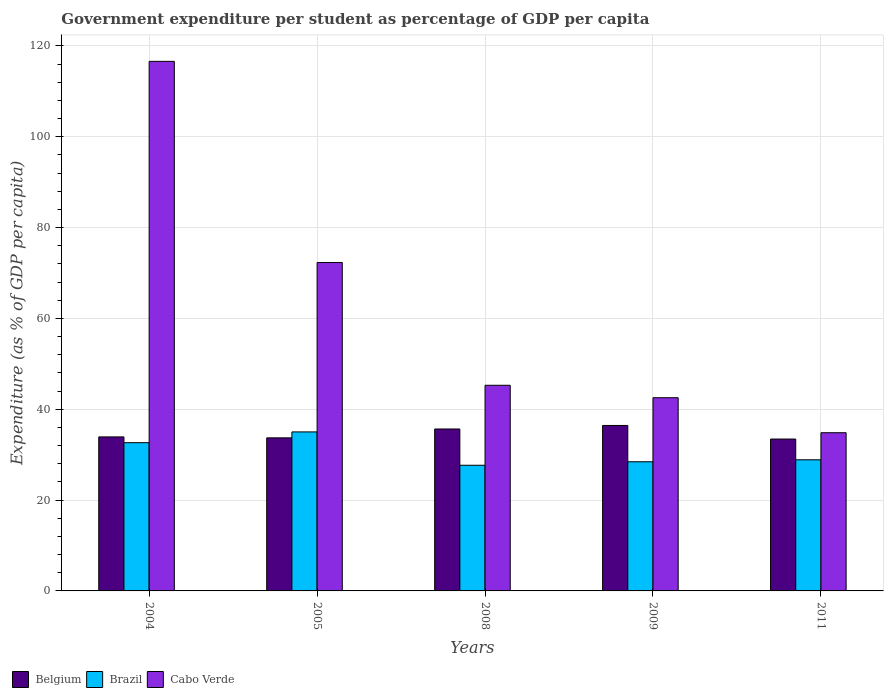Are the number of bars on each tick of the X-axis equal?
Ensure brevity in your answer.  Yes. How many bars are there on the 2nd tick from the left?
Your response must be concise. 3. How many bars are there on the 1st tick from the right?
Keep it short and to the point. 3. What is the label of the 2nd group of bars from the left?
Your answer should be very brief. 2005. In how many cases, is the number of bars for a given year not equal to the number of legend labels?
Provide a short and direct response. 0. What is the percentage of expenditure per student in Cabo Verde in 2008?
Keep it short and to the point. 45.28. Across all years, what is the maximum percentage of expenditure per student in Brazil?
Provide a succinct answer. 35.01. Across all years, what is the minimum percentage of expenditure per student in Brazil?
Offer a terse response. 27.67. What is the total percentage of expenditure per student in Belgium in the graph?
Provide a short and direct response. 173.16. What is the difference between the percentage of expenditure per student in Cabo Verde in 2005 and that in 2008?
Give a very brief answer. 27.03. What is the difference between the percentage of expenditure per student in Cabo Verde in 2008 and the percentage of expenditure per student in Brazil in 2005?
Your answer should be very brief. 10.27. What is the average percentage of expenditure per student in Belgium per year?
Your answer should be very brief. 34.63. In the year 2008, what is the difference between the percentage of expenditure per student in Brazil and percentage of expenditure per student in Belgium?
Make the answer very short. -7.99. What is the ratio of the percentage of expenditure per student in Cabo Verde in 2004 to that in 2005?
Your answer should be very brief. 1.61. Is the percentage of expenditure per student in Brazil in 2005 less than that in 2011?
Keep it short and to the point. No. Is the difference between the percentage of expenditure per student in Brazil in 2008 and 2009 greater than the difference between the percentage of expenditure per student in Belgium in 2008 and 2009?
Your response must be concise. Yes. What is the difference between the highest and the second highest percentage of expenditure per student in Brazil?
Your answer should be very brief. 2.38. What is the difference between the highest and the lowest percentage of expenditure per student in Belgium?
Keep it short and to the point. 2.99. In how many years, is the percentage of expenditure per student in Belgium greater than the average percentage of expenditure per student in Belgium taken over all years?
Offer a terse response. 2. Is the sum of the percentage of expenditure per student in Brazil in 2009 and 2011 greater than the maximum percentage of expenditure per student in Cabo Verde across all years?
Keep it short and to the point. No. What does the 3rd bar from the left in 2004 represents?
Your response must be concise. Cabo Verde. Is it the case that in every year, the sum of the percentage of expenditure per student in Brazil and percentage of expenditure per student in Belgium is greater than the percentage of expenditure per student in Cabo Verde?
Provide a succinct answer. No. How many bars are there?
Provide a succinct answer. 15. How many years are there in the graph?
Your answer should be compact. 5. What is the difference between two consecutive major ticks on the Y-axis?
Your answer should be very brief. 20. Are the values on the major ticks of Y-axis written in scientific E-notation?
Provide a short and direct response. No. How many legend labels are there?
Give a very brief answer. 3. How are the legend labels stacked?
Your answer should be compact. Horizontal. What is the title of the graph?
Provide a succinct answer. Government expenditure per student as percentage of GDP per capita. Does "Madagascar" appear as one of the legend labels in the graph?
Offer a very short reply. No. What is the label or title of the Y-axis?
Your response must be concise. Expenditure (as % of GDP per capita). What is the Expenditure (as % of GDP per capita) of Belgium in 2004?
Offer a very short reply. 33.91. What is the Expenditure (as % of GDP per capita) in Brazil in 2004?
Your response must be concise. 32.64. What is the Expenditure (as % of GDP per capita) of Cabo Verde in 2004?
Keep it short and to the point. 116.61. What is the Expenditure (as % of GDP per capita) in Belgium in 2005?
Your response must be concise. 33.71. What is the Expenditure (as % of GDP per capita) in Brazil in 2005?
Keep it short and to the point. 35.01. What is the Expenditure (as % of GDP per capita) of Cabo Verde in 2005?
Your answer should be very brief. 72.31. What is the Expenditure (as % of GDP per capita) in Belgium in 2008?
Offer a very short reply. 35.66. What is the Expenditure (as % of GDP per capita) of Brazil in 2008?
Provide a succinct answer. 27.67. What is the Expenditure (as % of GDP per capita) of Cabo Verde in 2008?
Your answer should be very brief. 45.28. What is the Expenditure (as % of GDP per capita) in Belgium in 2009?
Make the answer very short. 36.43. What is the Expenditure (as % of GDP per capita) in Brazil in 2009?
Your response must be concise. 28.44. What is the Expenditure (as % of GDP per capita) in Cabo Verde in 2009?
Offer a very short reply. 42.55. What is the Expenditure (as % of GDP per capita) of Belgium in 2011?
Ensure brevity in your answer.  33.44. What is the Expenditure (as % of GDP per capita) of Brazil in 2011?
Your answer should be compact. 28.87. What is the Expenditure (as % of GDP per capita) of Cabo Verde in 2011?
Offer a terse response. 34.84. Across all years, what is the maximum Expenditure (as % of GDP per capita) of Belgium?
Offer a very short reply. 36.43. Across all years, what is the maximum Expenditure (as % of GDP per capita) in Brazil?
Your response must be concise. 35.01. Across all years, what is the maximum Expenditure (as % of GDP per capita) of Cabo Verde?
Your response must be concise. 116.61. Across all years, what is the minimum Expenditure (as % of GDP per capita) of Belgium?
Offer a terse response. 33.44. Across all years, what is the minimum Expenditure (as % of GDP per capita) of Brazil?
Keep it short and to the point. 27.67. Across all years, what is the minimum Expenditure (as % of GDP per capita) in Cabo Verde?
Make the answer very short. 34.84. What is the total Expenditure (as % of GDP per capita) in Belgium in the graph?
Offer a terse response. 173.16. What is the total Expenditure (as % of GDP per capita) of Brazil in the graph?
Keep it short and to the point. 152.64. What is the total Expenditure (as % of GDP per capita) of Cabo Verde in the graph?
Provide a short and direct response. 311.59. What is the difference between the Expenditure (as % of GDP per capita) of Belgium in 2004 and that in 2005?
Keep it short and to the point. 0.21. What is the difference between the Expenditure (as % of GDP per capita) in Brazil in 2004 and that in 2005?
Make the answer very short. -2.38. What is the difference between the Expenditure (as % of GDP per capita) of Cabo Verde in 2004 and that in 2005?
Give a very brief answer. 44.3. What is the difference between the Expenditure (as % of GDP per capita) of Belgium in 2004 and that in 2008?
Your answer should be very brief. -1.75. What is the difference between the Expenditure (as % of GDP per capita) in Brazil in 2004 and that in 2008?
Offer a very short reply. 4.97. What is the difference between the Expenditure (as % of GDP per capita) in Cabo Verde in 2004 and that in 2008?
Provide a succinct answer. 71.33. What is the difference between the Expenditure (as % of GDP per capita) of Belgium in 2004 and that in 2009?
Provide a succinct answer. -2.52. What is the difference between the Expenditure (as % of GDP per capita) of Brazil in 2004 and that in 2009?
Your answer should be compact. 4.2. What is the difference between the Expenditure (as % of GDP per capita) of Cabo Verde in 2004 and that in 2009?
Your response must be concise. 74.07. What is the difference between the Expenditure (as % of GDP per capita) in Belgium in 2004 and that in 2011?
Your answer should be very brief. 0.47. What is the difference between the Expenditure (as % of GDP per capita) in Brazil in 2004 and that in 2011?
Keep it short and to the point. 3.76. What is the difference between the Expenditure (as % of GDP per capita) in Cabo Verde in 2004 and that in 2011?
Offer a terse response. 81.78. What is the difference between the Expenditure (as % of GDP per capita) of Belgium in 2005 and that in 2008?
Provide a succinct answer. -1.95. What is the difference between the Expenditure (as % of GDP per capita) of Brazil in 2005 and that in 2008?
Give a very brief answer. 7.34. What is the difference between the Expenditure (as % of GDP per capita) in Cabo Verde in 2005 and that in 2008?
Offer a terse response. 27.03. What is the difference between the Expenditure (as % of GDP per capita) of Belgium in 2005 and that in 2009?
Provide a succinct answer. -2.73. What is the difference between the Expenditure (as % of GDP per capita) of Brazil in 2005 and that in 2009?
Keep it short and to the point. 6.57. What is the difference between the Expenditure (as % of GDP per capita) of Cabo Verde in 2005 and that in 2009?
Offer a very short reply. 29.77. What is the difference between the Expenditure (as % of GDP per capita) of Belgium in 2005 and that in 2011?
Ensure brevity in your answer.  0.26. What is the difference between the Expenditure (as % of GDP per capita) in Brazil in 2005 and that in 2011?
Ensure brevity in your answer.  6.14. What is the difference between the Expenditure (as % of GDP per capita) of Cabo Verde in 2005 and that in 2011?
Keep it short and to the point. 37.48. What is the difference between the Expenditure (as % of GDP per capita) in Belgium in 2008 and that in 2009?
Give a very brief answer. -0.77. What is the difference between the Expenditure (as % of GDP per capita) in Brazil in 2008 and that in 2009?
Provide a short and direct response. -0.77. What is the difference between the Expenditure (as % of GDP per capita) of Cabo Verde in 2008 and that in 2009?
Provide a short and direct response. 2.74. What is the difference between the Expenditure (as % of GDP per capita) of Belgium in 2008 and that in 2011?
Make the answer very short. 2.21. What is the difference between the Expenditure (as % of GDP per capita) in Brazil in 2008 and that in 2011?
Give a very brief answer. -1.2. What is the difference between the Expenditure (as % of GDP per capita) in Cabo Verde in 2008 and that in 2011?
Your answer should be very brief. 10.45. What is the difference between the Expenditure (as % of GDP per capita) of Belgium in 2009 and that in 2011?
Keep it short and to the point. 2.99. What is the difference between the Expenditure (as % of GDP per capita) in Brazil in 2009 and that in 2011?
Your answer should be compact. -0.43. What is the difference between the Expenditure (as % of GDP per capita) in Cabo Verde in 2009 and that in 2011?
Your answer should be compact. 7.71. What is the difference between the Expenditure (as % of GDP per capita) of Belgium in 2004 and the Expenditure (as % of GDP per capita) of Brazil in 2005?
Make the answer very short. -1.1. What is the difference between the Expenditure (as % of GDP per capita) in Belgium in 2004 and the Expenditure (as % of GDP per capita) in Cabo Verde in 2005?
Provide a short and direct response. -38.4. What is the difference between the Expenditure (as % of GDP per capita) in Brazil in 2004 and the Expenditure (as % of GDP per capita) in Cabo Verde in 2005?
Your answer should be compact. -39.67. What is the difference between the Expenditure (as % of GDP per capita) in Belgium in 2004 and the Expenditure (as % of GDP per capita) in Brazil in 2008?
Keep it short and to the point. 6.24. What is the difference between the Expenditure (as % of GDP per capita) in Belgium in 2004 and the Expenditure (as % of GDP per capita) in Cabo Verde in 2008?
Offer a very short reply. -11.37. What is the difference between the Expenditure (as % of GDP per capita) in Brazil in 2004 and the Expenditure (as % of GDP per capita) in Cabo Verde in 2008?
Your answer should be very brief. -12.65. What is the difference between the Expenditure (as % of GDP per capita) in Belgium in 2004 and the Expenditure (as % of GDP per capita) in Brazil in 2009?
Make the answer very short. 5.47. What is the difference between the Expenditure (as % of GDP per capita) in Belgium in 2004 and the Expenditure (as % of GDP per capita) in Cabo Verde in 2009?
Your answer should be very brief. -8.63. What is the difference between the Expenditure (as % of GDP per capita) of Brazil in 2004 and the Expenditure (as % of GDP per capita) of Cabo Verde in 2009?
Ensure brevity in your answer.  -9.91. What is the difference between the Expenditure (as % of GDP per capita) of Belgium in 2004 and the Expenditure (as % of GDP per capita) of Brazil in 2011?
Ensure brevity in your answer.  5.04. What is the difference between the Expenditure (as % of GDP per capita) of Belgium in 2004 and the Expenditure (as % of GDP per capita) of Cabo Verde in 2011?
Your response must be concise. -0.92. What is the difference between the Expenditure (as % of GDP per capita) of Brazil in 2004 and the Expenditure (as % of GDP per capita) of Cabo Verde in 2011?
Offer a terse response. -2.2. What is the difference between the Expenditure (as % of GDP per capita) of Belgium in 2005 and the Expenditure (as % of GDP per capita) of Brazil in 2008?
Your answer should be compact. 6.04. What is the difference between the Expenditure (as % of GDP per capita) of Belgium in 2005 and the Expenditure (as % of GDP per capita) of Cabo Verde in 2008?
Make the answer very short. -11.58. What is the difference between the Expenditure (as % of GDP per capita) in Brazil in 2005 and the Expenditure (as % of GDP per capita) in Cabo Verde in 2008?
Offer a terse response. -10.27. What is the difference between the Expenditure (as % of GDP per capita) in Belgium in 2005 and the Expenditure (as % of GDP per capita) in Brazil in 2009?
Make the answer very short. 5.27. What is the difference between the Expenditure (as % of GDP per capita) of Belgium in 2005 and the Expenditure (as % of GDP per capita) of Cabo Verde in 2009?
Keep it short and to the point. -8.84. What is the difference between the Expenditure (as % of GDP per capita) of Brazil in 2005 and the Expenditure (as % of GDP per capita) of Cabo Verde in 2009?
Your answer should be very brief. -7.53. What is the difference between the Expenditure (as % of GDP per capita) in Belgium in 2005 and the Expenditure (as % of GDP per capita) in Brazil in 2011?
Make the answer very short. 4.83. What is the difference between the Expenditure (as % of GDP per capita) in Belgium in 2005 and the Expenditure (as % of GDP per capita) in Cabo Verde in 2011?
Your response must be concise. -1.13. What is the difference between the Expenditure (as % of GDP per capita) in Brazil in 2005 and the Expenditure (as % of GDP per capita) in Cabo Verde in 2011?
Give a very brief answer. 0.18. What is the difference between the Expenditure (as % of GDP per capita) in Belgium in 2008 and the Expenditure (as % of GDP per capita) in Brazil in 2009?
Provide a short and direct response. 7.22. What is the difference between the Expenditure (as % of GDP per capita) of Belgium in 2008 and the Expenditure (as % of GDP per capita) of Cabo Verde in 2009?
Offer a very short reply. -6.89. What is the difference between the Expenditure (as % of GDP per capita) of Brazil in 2008 and the Expenditure (as % of GDP per capita) of Cabo Verde in 2009?
Offer a terse response. -14.87. What is the difference between the Expenditure (as % of GDP per capita) in Belgium in 2008 and the Expenditure (as % of GDP per capita) in Brazil in 2011?
Make the answer very short. 6.78. What is the difference between the Expenditure (as % of GDP per capita) in Belgium in 2008 and the Expenditure (as % of GDP per capita) in Cabo Verde in 2011?
Your response must be concise. 0.82. What is the difference between the Expenditure (as % of GDP per capita) of Brazil in 2008 and the Expenditure (as % of GDP per capita) of Cabo Verde in 2011?
Make the answer very short. -7.16. What is the difference between the Expenditure (as % of GDP per capita) of Belgium in 2009 and the Expenditure (as % of GDP per capita) of Brazil in 2011?
Your answer should be very brief. 7.56. What is the difference between the Expenditure (as % of GDP per capita) of Belgium in 2009 and the Expenditure (as % of GDP per capita) of Cabo Verde in 2011?
Your response must be concise. 1.6. What is the difference between the Expenditure (as % of GDP per capita) of Brazil in 2009 and the Expenditure (as % of GDP per capita) of Cabo Verde in 2011?
Provide a succinct answer. -6.4. What is the average Expenditure (as % of GDP per capita) of Belgium per year?
Keep it short and to the point. 34.63. What is the average Expenditure (as % of GDP per capita) in Brazil per year?
Your response must be concise. 30.53. What is the average Expenditure (as % of GDP per capita) of Cabo Verde per year?
Offer a very short reply. 62.32. In the year 2004, what is the difference between the Expenditure (as % of GDP per capita) of Belgium and Expenditure (as % of GDP per capita) of Brazil?
Your answer should be very brief. 1.27. In the year 2004, what is the difference between the Expenditure (as % of GDP per capita) of Belgium and Expenditure (as % of GDP per capita) of Cabo Verde?
Give a very brief answer. -82.7. In the year 2004, what is the difference between the Expenditure (as % of GDP per capita) in Brazil and Expenditure (as % of GDP per capita) in Cabo Verde?
Provide a succinct answer. -83.97. In the year 2005, what is the difference between the Expenditure (as % of GDP per capita) in Belgium and Expenditure (as % of GDP per capita) in Brazil?
Your answer should be very brief. -1.31. In the year 2005, what is the difference between the Expenditure (as % of GDP per capita) of Belgium and Expenditure (as % of GDP per capita) of Cabo Verde?
Give a very brief answer. -38.6. In the year 2005, what is the difference between the Expenditure (as % of GDP per capita) of Brazil and Expenditure (as % of GDP per capita) of Cabo Verde?
Your answer should be compact. -37.3. In the year 2008, what is the difference between the Expenditure (as % of GDP per capita) of Belgium and Expenditure (as % of GDP per capita) of Brazil?
Offer a terse response. 7.99. In the year 2008, what is the difference between the Expenditure (as % of GDP per capita) in Belgium and Expenditure (as % of GDP per capita) in Cabo Verde?
Ensure brevity in your answer.  -9.63. In the year 2008, what is the difference between the Expenditure (as % of GDP per capita) of Brazil and Expenditure (as % of GDP per capita) of Cabo Verde?
Give a very brief answer. -17.61. In the year 2009, what is the difference between the Expenditure (as % of GDP per capita) of Belgium and Expenditure (as % of GDP per capita) of Brazil?
Provide a short and direct response. 7.99. In the year 2009, what is the difference between the Expenditure (as % of GDP per capita) of Belgium and Expenditure (as % of GDP per capita) of Cabo Verde?
Make the answer very short. -6.11. In the year 2009, what is the difference between the Expenditure (as % of GDP per capita) of Brazil and Expenditure (as % of GDP per capita) of Cabo Verde?
Provide a short and direct response. -14.11. In the year 2011, what is the difference between the Expenditure (as % of GDP per capita) in Belgium and Expenditure (as % of GDP per capita) in Brazil?
Give a very brief answer. 4.57. In the year 2011, what is the difference between the Expenditure (as % of GDP per capita) of Belgium and Expenditure (as % of GDP per capita) of Cabo Verde?
Ensure brevity in your answer.  -1.39. In the year 2011, what is the difference between the Expenditure (as % of GDP per capita) in Brazil and Expenditure (as % of GDP per capita) in Cabo Verde?
Provide a succinct answer. -5.96. What is the ratio of the Expenditure (as % of GDP per capita) of Belgium in 2004 to that in 2005?
Your answer should be compact. 1.01. What is the ratio of the Expenditure (as % of GDP per capita) of Brazil in 2004 to that in 2005?
Give a very brief answer. 0.93. What is the ratio of the Expenditure (as % of GDP per capita) in Cabo Verde in 2004 to that in 2005?
Provide a short and direct response. 1.61. What is the ratio of the Expenditure (as % of GDP per capita) in Belgium in 2004 to that in 2008?
Make the answer very short. 0.95. What is the ratio of the Expenditure (as % of GDP per capita) in Brazil in 2004 to that in 2008?
Keep it short and to the point. 1.18. What is the ratio of the Expenditure (as % of GDP per capita) in Cabo Verde in 2004 to that in 2008?
Provide a short and direct response. 2.58. What is the ratio of the Expenditure (as % of GDP per capita) of Belgium in 2004 to that in 2009?
Ensure brevity in your answer.  0.93. What is the ratio of the Expenditure (as % of GDP per capita) of Brazil in 2004 to that in 2009?
Your answer should be very brief. 1.15. What is the ratio of the Expenditure (as % of GDP per capita) of Cabo Verde in 2004 to that in 2009?
Provide a succinct answer. 2.74. What is the ratio of the Expenditure (as % of GDP per capita) in Belgium in 2004 to that in 2011?
Keep it short and to the point. 1.01. What is the ratio of the Expenditure (as % of GDP per capita) of Brazil in 2004 to that in 2011?
Keep it short and to the point. 1.13. What is the ratio of the Expenditure (as % of GDP per capita) in Cabo Verde in 2004 to that in 2011?
Provide a short and direct response. 3.35. What is the ratio of the Expenditure (as % of GDP per capita) of Belgium in 2005 to that in 2008?
Ensure brevity in your answer.  0.95. What is the ratio of the Expenditure (as % of GDP per capita) of Brazil in 2005 to that in 2008?
Offer a terse response. 1.27. What is the ratio of the Expenditure (as % of GDP per capita) of Cabo Verde in 2005 to that in 2008?
Provide a short and direct response. 1.6. What is the ratio of the Expenditure (as % of GDP per capita) of Belgium in 2005 to that in 2009?
Give a very brief answer. 0.93. What is the ratio of the Expenditure (as % of GDP per capita) of Brazil in 2005 to that in 2009?
Make the answer very short. 1.23. What is the ratio of the Expenditure (as % of GDP per capita) in Cabo Verde in 2005 to that in 2009?
Give a very brief answer. 1.7. What is the ratio of the Expenditure (as % of GDP per capita) of Belgium in 2005 to that in 2011?
Keep it short and to the point. 1.01. What is the ratio of the Expenditure (as % of GDP per capita) of Brazil in 2005 to that in 2011?
Make the answer very short. 1.21. What is the ratio of the Expenditure (as % of GDP per capita) in Cabo Verde in 2005 to that in 2011?
Give a very brief answer. 2.08. What is the ratio of the Expenditure (as % of GDP per capita) in Belgium in 2008 to that in 2009?
Offer a terse response. 0.98. What is the ratio of the Expenditure (as % of GDP per capita) in Brazil in 2008 to that in 2009?
Give a very brief answer. 0.97. What is the ratio of the Expenditure (as % of GDP per capita) of Cabo Verde in 2008 to that in 2009?
Make the answer very short. 1.06. What is the ratio of the Expenditure (as % of GDP per capita) in Belgium in 2008 to that in 2011?
Provide a succinct answer. 1.07. What is the ratio of the Expenditure (as % of GDP per capita) in Brazil in 2008 to that in 2011?
Offer a very short reply. 0.96. What is the ratio of the Expenditure (as % of GDP per capita) in Cabo Verde in 2008 to that in 2011?
Keep it short and to the point. 1.3. What is the ratio of the Expenditure (as % of GDP per capita) in Belgium in 2009 to that in 2011?
Provide a short and direct response. 1.09. What is the ratio of the Expenditure (as % of GDP per capita) in Brazil in 2009 to that in 2011?
Make the answer very short. 0.98. What is the ratio of the Expenditure (as % of GDP per capita) in Cabo Verde in 2009 to that in 2011?
Keep it short and to the point. 1.22. What is the difference between the highest and the second highest Expenditure (as % of GDP per capita) of Belgium?
Your answer should be very brief. 0.77. What is the difference between the highest and the second highest Expenditure (as % of GDP per capita) in Brazil?
Your answer should be compact. 2.38. What is the difference between the highest and the second highest Expenditure (as % of GDP per capita) in Cabo Verde?
Your answer should be very brief. 44.3. What is the difference between the highest and the lowest Expenditure (as % of GDP per capita) in Belgium?
Make the answer very short. 2.99. What is the difference between the highest and the lowest Expenditure (as % of GDP per capita) in Brazil?
Keep it short and to the point. 7.34. What is the difference between the highest and the lowest Expenditure (as % of GDP per capita) in Cabo Verde?
Offer a very short reply. 81.78. 